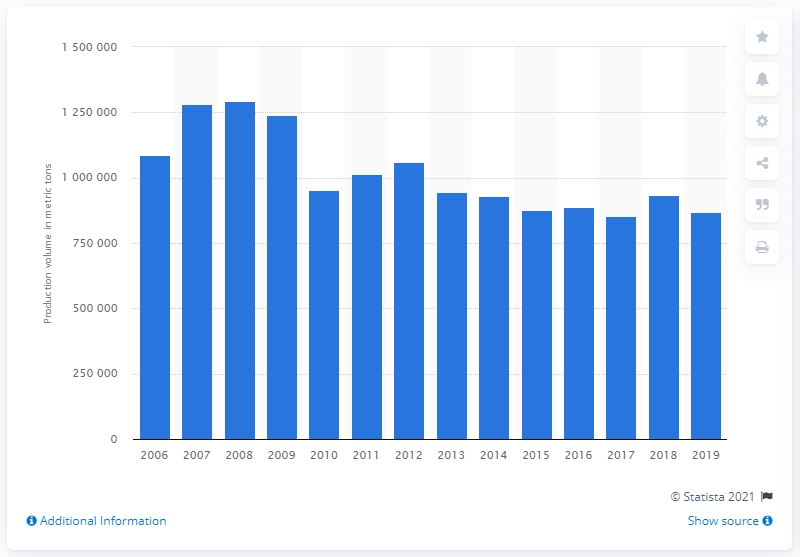Highlight a few significant elements in this photo. In 2019, the domestic demand for composite fertilizer in South Korea was approximately 869,044 tons. 